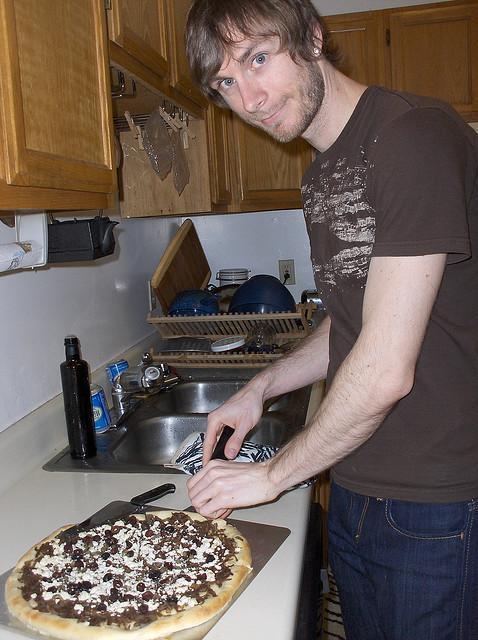What company is known for making the item that is on the counter?
Indicate the correct choice and explain in the format: 'Answer: answer
Rationale: rationale.'
Options: Domino's, mcdonald's, nathan's, gorton's. Answer: domino's.
Rationale: Domino's is a pizza chain. 